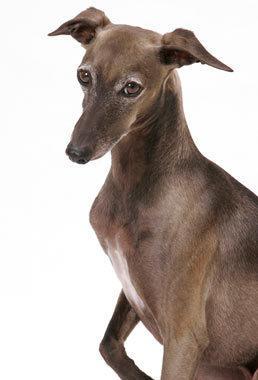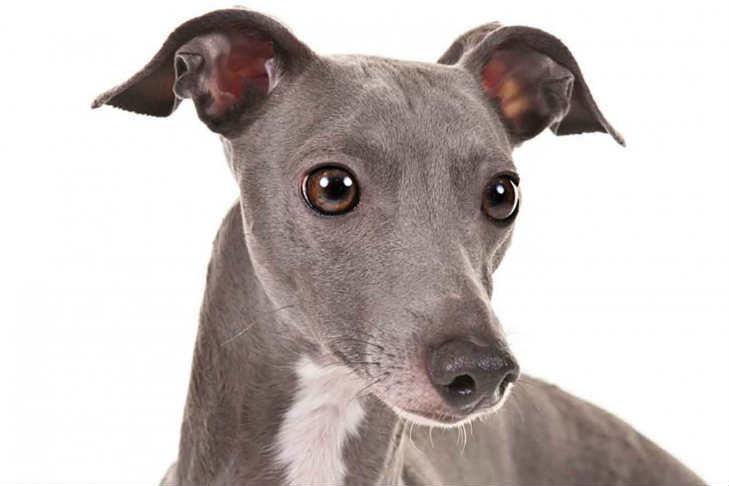The first image is the image on the left, the second image is the image on the right. For the images displayed, is the sentence "Dog has a grey (blue) and white color." factually correct? Answer yes or no. Yes. 